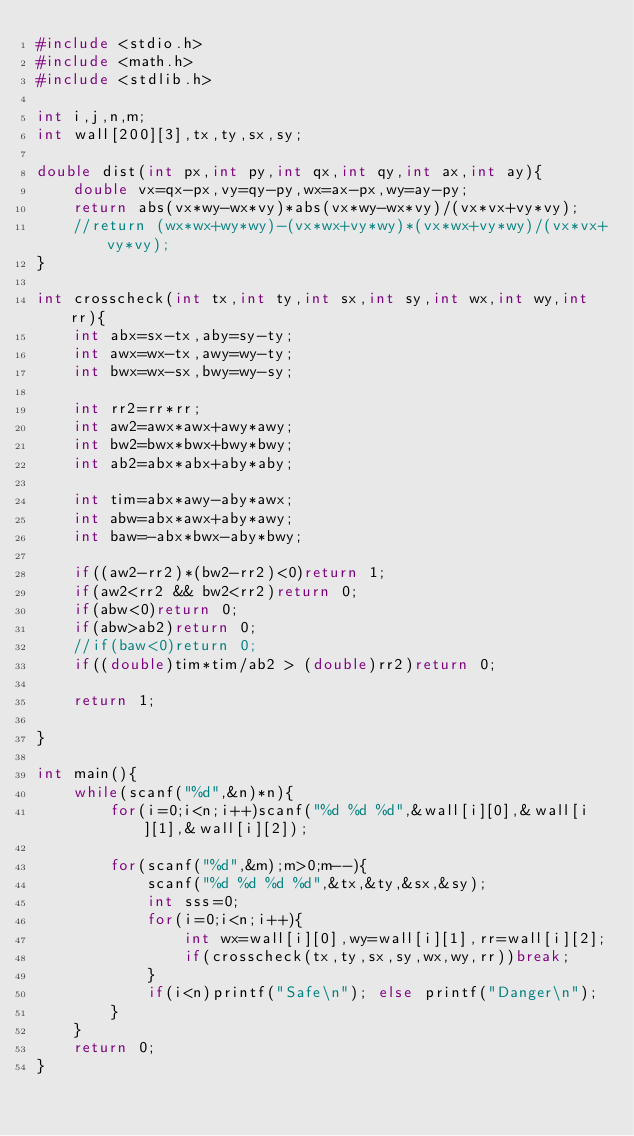Convert code to text. <code><loc_0><loc_0><loc_500><loc_500><_C_>#include <stdio.h>
#include <math.h>
#include <stdlib.h>

int i,j,n,m;
int wall[200][3],tx,ty,sx,sy;

double dist(int px,int py,int qx,int qy,int ax,int ay){
	double vx=qx-px,vy=qy-py,wx=ax-px,wy=ay-py;
	return abs(vx*wy-wx*vy)*abs(vx*wy-wx*vy)/(vx*vx+vy*vy);
	//return (wx*wx+wy*wy)-(vx*wx+vy*wy)*(vx*wx+vy*wy)/(vx*vx+vy*vy);
}

int crosscheck(int tx,int ty,int sx,int sy,int wx,int wy,int rr){
	int abx=sx-tx,aby=sy-ty;
	int awx=wx-tx,awy=wy-ty;
	int bwx=wx-sx,bwy=wy-sy;

	int rr2=rr*rr;
	int aw2=awx*awx+awy*awy;
	int bw2=bwx*bwx+bwy*bwy;
	int ab2=abx*abx+aby*aby;

	int tim=abx*awy-aby*awx;
	int abw=abx*awx+aby*awy;
	int baw=-abx*bwx-aby*bwy;

	if((aw2-rr2)*(bw2-rr2)<0)return 1;
	if(aw2<rr2 && bw2<rr2)return 0;
	if(abw<0)return 0;
	if(abw>ab2)return 0;
	//if(baw<0)return 0;
	if((double)tim*tim/ab2 > (double)rr2)return 0;
	
	return 1;

}

int main(){
	while(scanf("%d",&n)*n){
		for(i=0;i<n;i++)scanf("%d %d %d",&wall[i][0],&wall[i][1],&wall[i][2]);

		for(scanf("%d",&m);m>0;m--){
			scanf("%d %d %d %d",&tx,&ty,&sx,&sy);
			int sss=0;
			for(i=0;i<n;i++){
				int wx=wall[i][0],wy=wall[i][1],rr=wall[i][2];
				if(crosscheck(tx,ty,sx,sy,wx,wy,rr))break;
			}
			if(i<n)printf("Safe\n"); else printf("Danger\n");
		}
	}
	return 0;
}</code> 